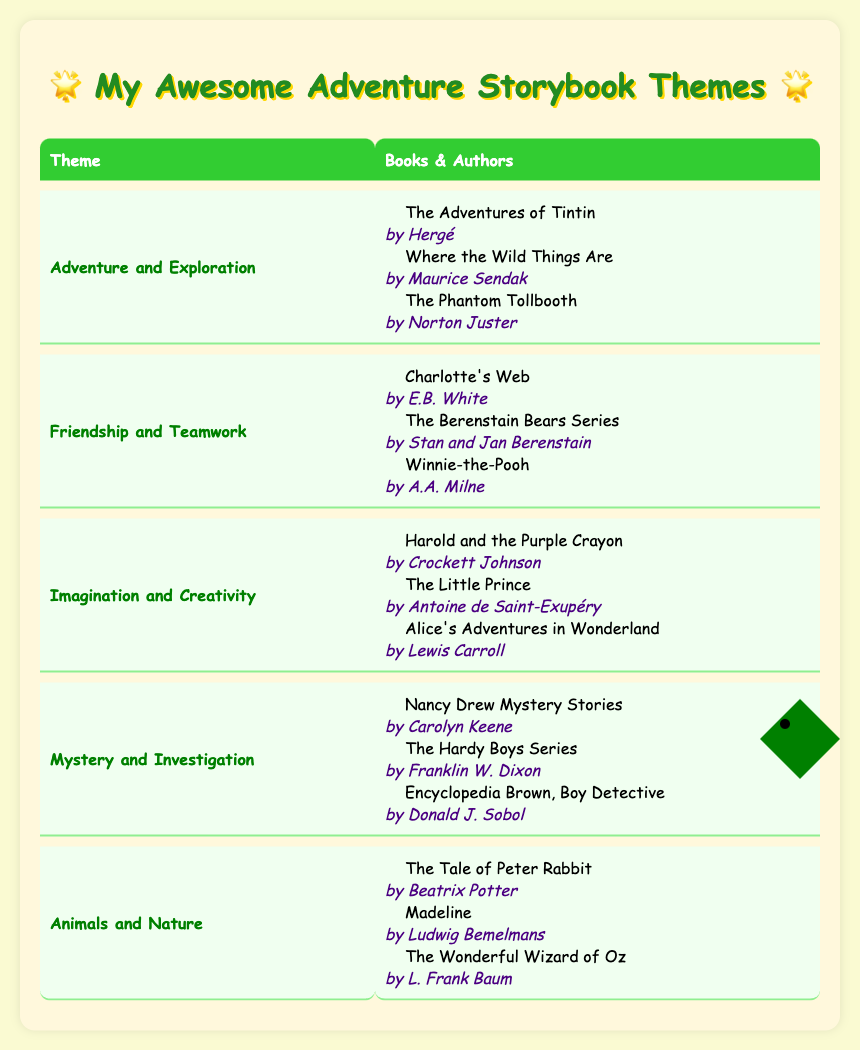What is one book from the theme "Adventure and Exploration"? From the table, under the theme "Adventure and Exploration," one of the listed books is "The Adventures of Tintin."
Answer: The Adventures of Tintin Who is the author of "Charlotte's Web"? "Charlotte's Web" is listed under the theme "Friendship and Teamwork," and the author mentioned next to it is E.B. White.
Answer: E.B. White Are there books listed under the theme "Imagination and Creativity"? Yes, the table shows multiple books, such as "Harold and the Purple Crayon," "The Little Prince," and "Alice's Adventures in Wonderland," under the theme "Imagination and Creativity."
Answer: Yes How many themes are in the table? The table presents five different themes: Adventure and Exploration, Friendship and Teamwork, Imagination and Creativity, Mystery and Investigation, and Animals and Nature, making it a total of five themes.
Answer: 5 Which theme has "Nancy Drew Mystery Stories" as a book? “Nancy Drew Mystery Stories” is found in the theme "Mystery and Investigation," as per the details provided in the table.
Answer: Mystery and Investigation What are the names of the authors for the books listed under the theme "Animals and Nature"? The authors for the books under "Animals and Nature" are Beatrix Potter (The Tale of Peter Rabbit), Ludwig Bemelmans (Madeline), and L. Frank Baum (The Wonderful Wizard of Oz).
Answer: Beatrix Potter, Ludwig Bemelmans, L. Frank Baum If I wanted to find a story about friendship, which book would I pick from the table? In the theme "Friendship and Teamwork," one can pick "Winnie-the-Pooh," which is listed as a book under that theme.
Answer: Winnie-the-Pooh Which author appears in both the themes "Friendship and Teamwork" and "Animals and Nature"? A.A. Milne appears only under "Friendship and Teamwork" as the author of "Winnie-the-Pooh." Looking at the table, he doesn't appear under "Animals and Nature." Hence, no author fits this criterion.
Answer: None 